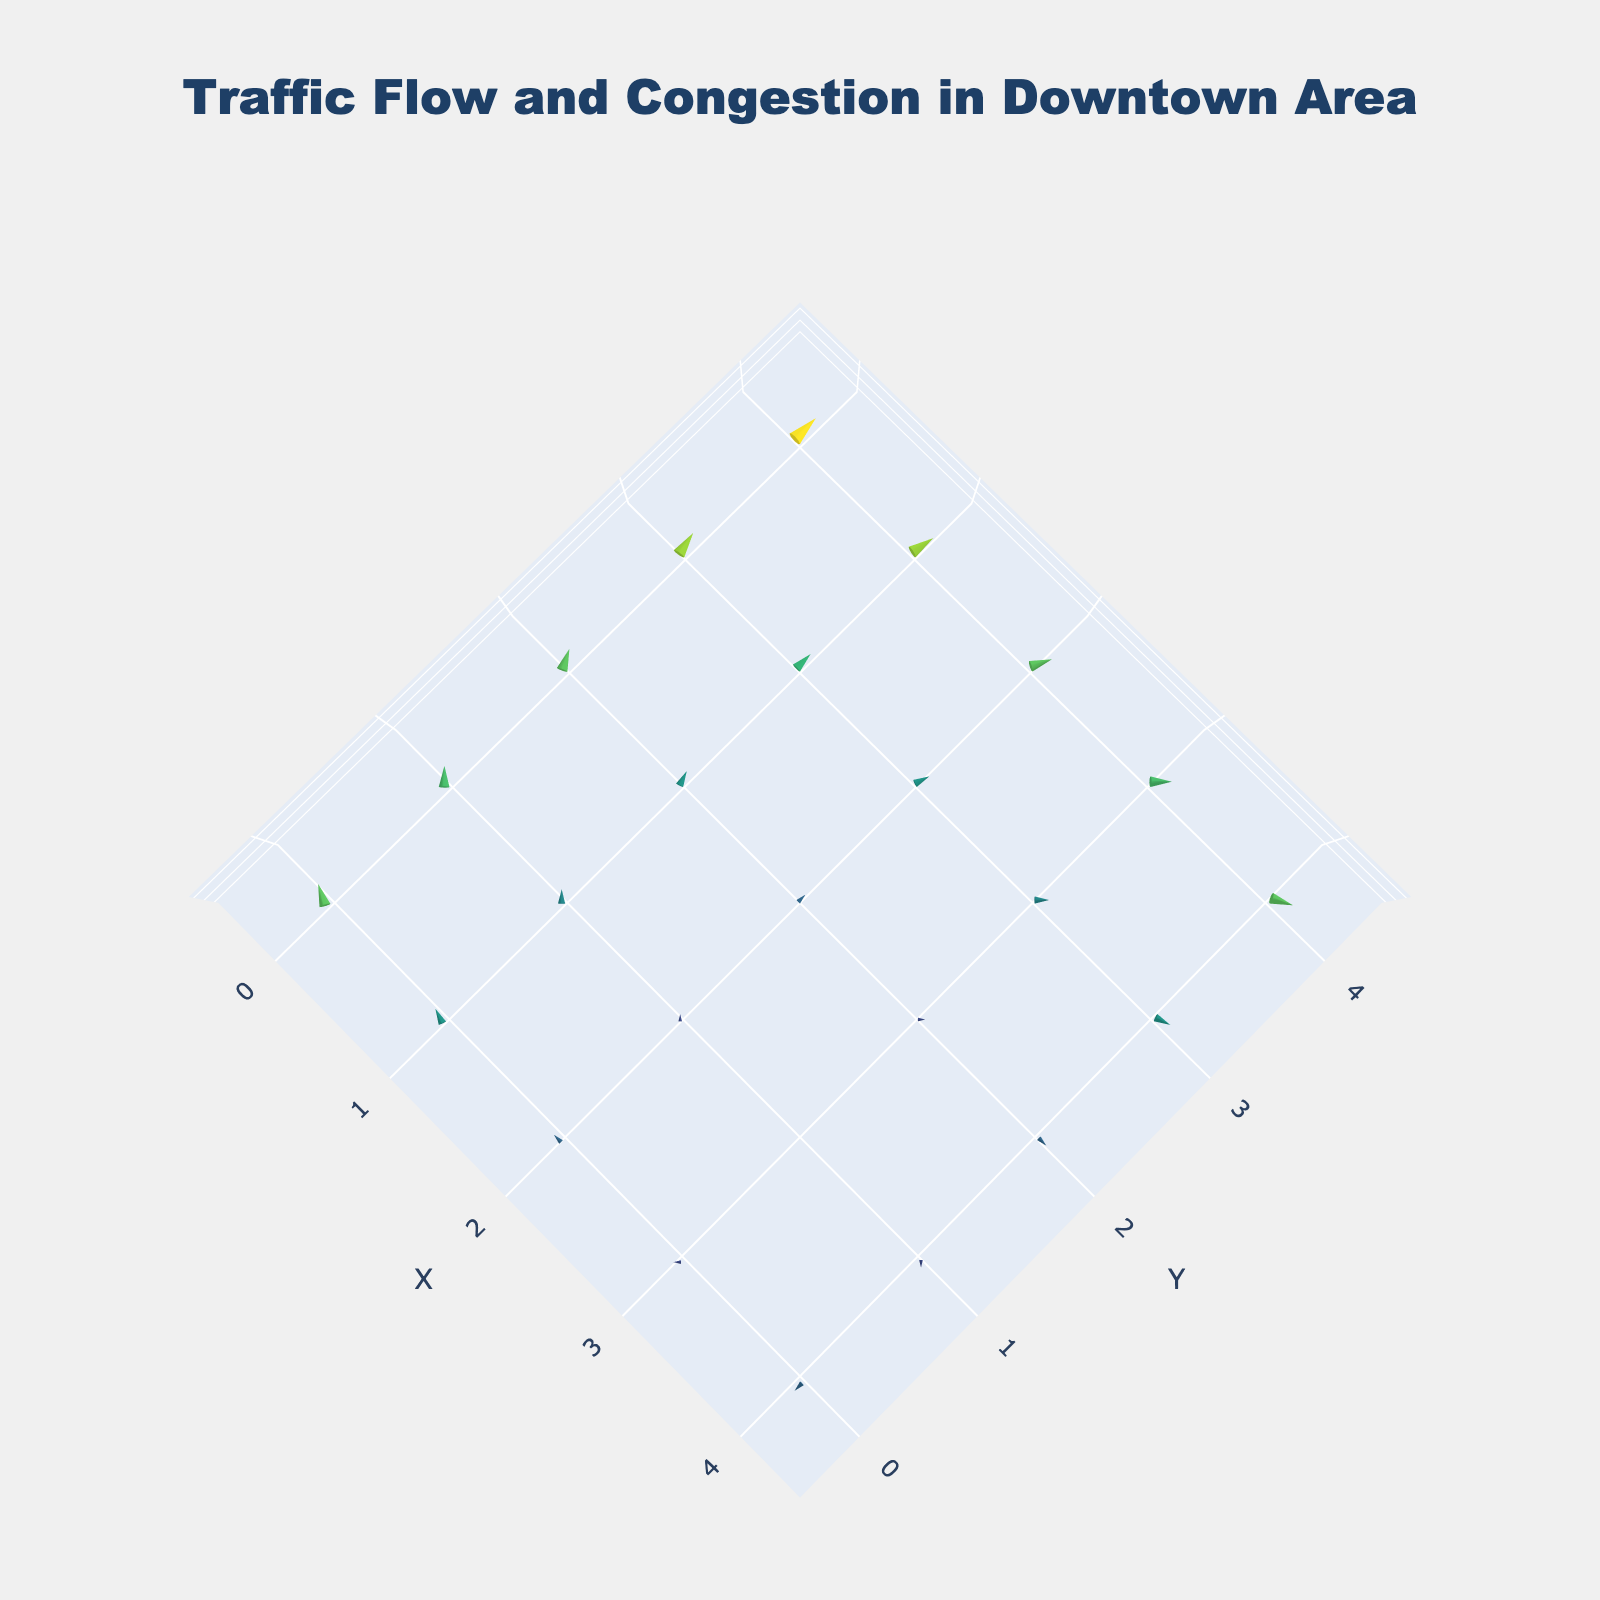What's the title of the figure? The title is located at the top center of the figure and is indicated by its larger, prominent text. It reads "Traffic Flow and Congestion in Downtown Area."
Answer: Traffic Flow and Congestion in Downtown Area How many grid points are displayed on the plot? The plot contains a 5x5 grid with points at coordinates ranging from (0,0) to (4,4). By counting the grid points, there are a total of 25 points.
Answer: 25 In which direction is the traffic flow the strongest? The traffic flow is indicated by the length of the arrows. The point (0,4) has the longest upward arrow representing a strong upward flow, suggesting strong northward traffic.
Answer: Northward (upward) How does the traffic flow at (2, 2) compare to that at (0, 4)? The arrow at (2, 2) points upward and is relatively shorter, indicating less intense flow compared to (0, 4) where the arrow is much longer and points upward. This implies that the traffic flow at (0, 4) is stronger than at (2, 2).
Answer: (0, 4) has a stronger flow What is the traffic direction at coordinates (4, 0)? At (4, 0), the arrow points directly downward, indicating traffic flowing south.
Answer: South Which points show no horizontal traffic flow? The arrows at coordinates where the x-component of vectors (u) is zero indicate no horizontal flow. Such points are (3,1), (2,2), (1,3), and (4,0).
Answer: (3,1), (2,2), (1,3), (4,0) What is the visual difference between the arrows at points (0, 2) and (3, 4)? The arrow at (0, 2) is longer and points upwards, while the arrow at (3, 4) is a shorter arrow with a north-east direction. The visual difference highlights that traffic at (0, 2) is stronger and more northward compared to (3, 4).
Answer: (0,2) is longer and northward; (3,4) is shorter and north-east What's the average length of the traffic arrows along the X-axis row y=0? Add the magnitudes of the arrows along the row y=0 (2.5 + 2 + 1.5 + 1 + 1.5) and divide by the number of points, resulting in (2.5 + 2 + 1.5 + 1 + 1.5) / 5 = 1.7
Answer: 1.7 